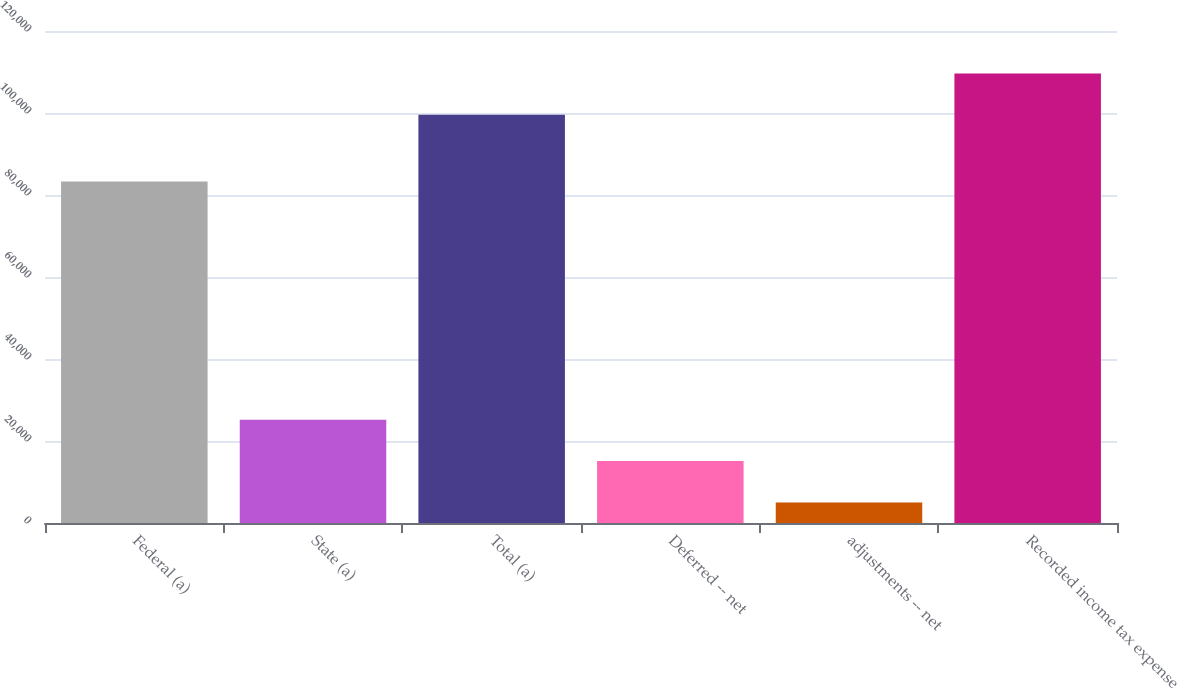<chart> <loc_0><loc_0><loc_500><loc_500><bar_chart><fcel>Federal (a)<fcel>State (a)<fcel>Total (a)<fcel>Deferred -- net<fcel>adjustments -- net<fcel>Recorded income tax expense<nl><fcel>83314<fcel>25206.6<fcel>99544<fcel>15115.8<fcel>5025<fcel>109635<nl></chart> 